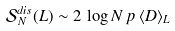<formula> <loc_0><loc_0><loc_500><loc_500>\mathcal { S } ^ { d i s } _ { N } ( L ) \sim 2 \, \log N \, p \, \langle D \rangle _ { L }</formula> 